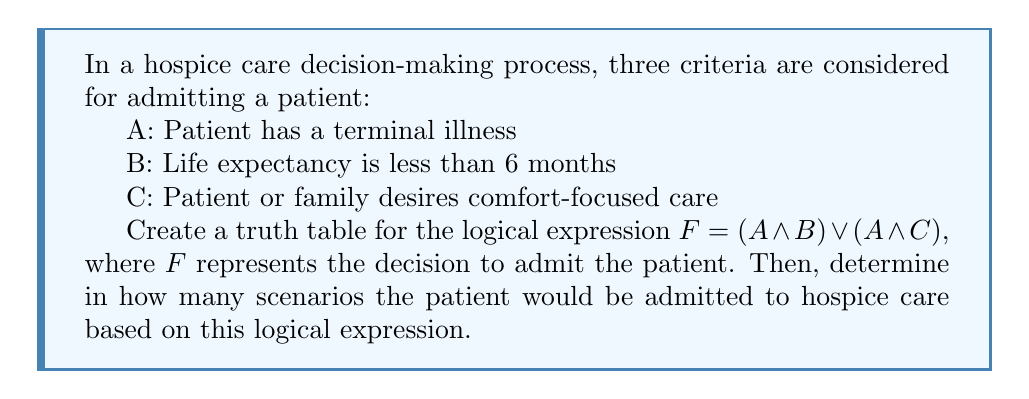Can you answer this question? To solve this problem, we need to follow these steps:

1. Identify the variables: A, B, and C
2. Create a truth table with all possible combinations of these variables
3. Evaluate the expression $F = (A \land B) \lor (A \land C)$ for each combination
4. Count the number of scenarios where $F$ is true (1)

Step 1: We have already identified the variables A, B, and C.

Step 2: Create the truth table with 8 rows (2^3 combinations):

| A | B | C | $(A \land B)$ | $(A \land C)$ | $F = (A \land B) \lor (A \land C)$ |
|---|---|---|---------------|---------------|-------------------------------------|
| 0 | 0 | 0 |       0       |       0       |                 0                   |
| 0 | 0 | 1 |       0       |       0       |                 0                   |
| 0 | 1 | 0 |       0       |       0       |                 0                   |
| 0 | 1 | 1 |       0       |       0       |                 0                   |
| 1 | 0 | 0 |       0       |       0       |                 0                   |
| 1 | 0 | 1 |       0       |       1       |                 1                   |
| 1 | 1 | 0 |       1       |       0       |                 1                   |
| 1 | 1 | 1 |       1       |       1       |                 1                   |

Step 3: We have evaluated the expression for each combination in the rightmost column.

Step 4: Count the number of scenarios where $F$ is true (1). From the truth table, we can see that there are 3 scenarios where $F$ is true.

Therefore, based on this logical expression, the patient would be admitted to hospice care in 3 different scenarios.
Answer: 3 scenarios 